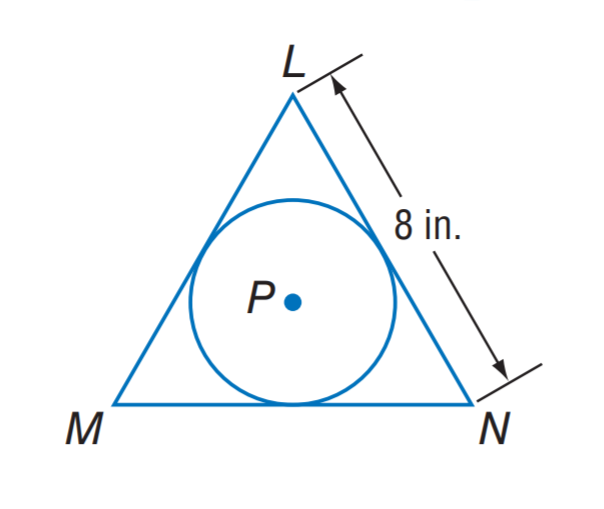Question: \odot P is inscribed in equilateral triangle L M N. What is the circumference of \odot P?
Choices:
A. \frac { 8 } { 3 } \pi
B. \frac { 8 } { \sqrt 3 } \pi
C. 8 \sqrt 3 \pi
D. 24 \pi
Answer with the letter. Answer: B 